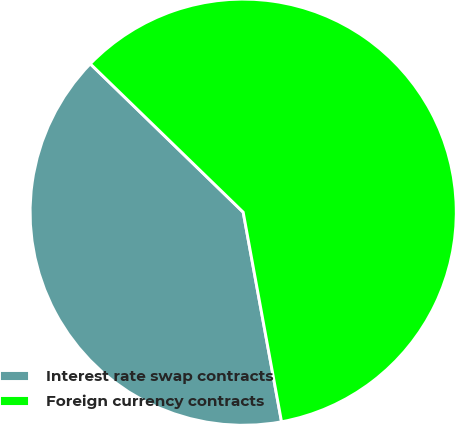Convert chart. <chart><loc_0><loc_0><loc_500><loc_500><pie_chart><fcel>Interest rate swap contracts<fcel>Foreign currency contracts<nl><fcel>40.14%<fcel>59.86%<nl></chart> 